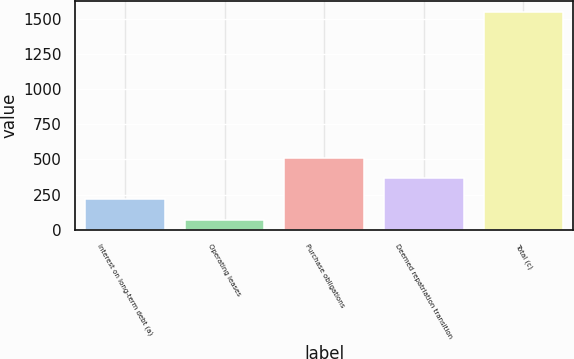Convert chart. <chart><loc_0><loc_0><loc_500><loc_500><bar_chart><fcel>Interest on long-term debt (a)<fcel>Operating leases<fcel>Purchase obligations<fcel>Deemed repatriation transition<fcel>Total (c)<nl><fcel>217.2<fcel>69<fcel>513.6<fcel>365.4<fcel>1551<nl></chart> 